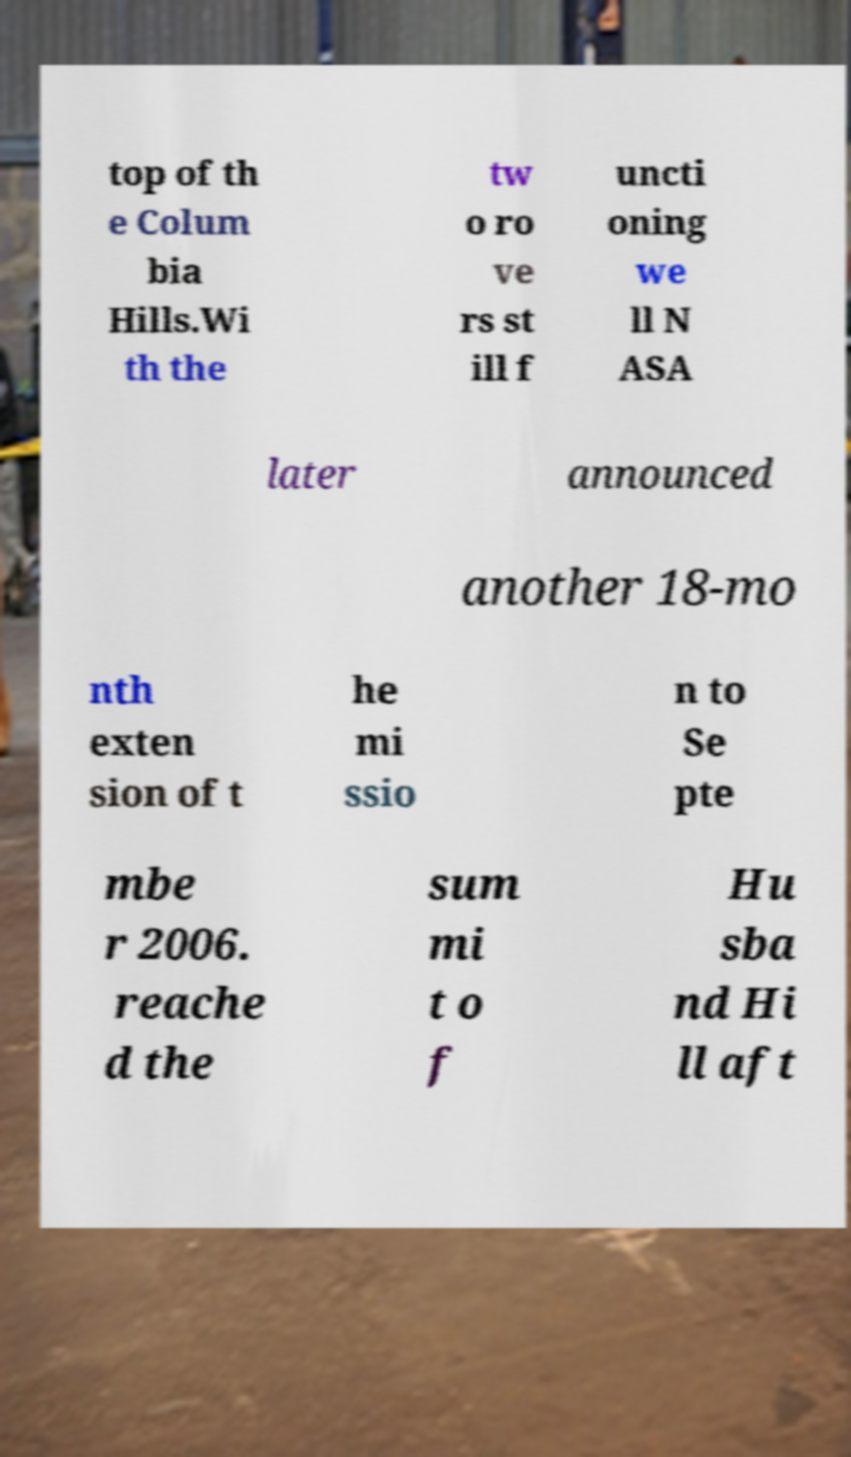Please read and relay the text visible in this image. What does it say? top of th e Colum bia Hills.Wi th the tw o ro ve rs st ill f uncti oning we ll N ASA later announced another 18-mo nth exten sion of t he mi ssio n to Se pte mbe r 2006. reache d the sum mi t o f Hu sba nd Hi ll aft 